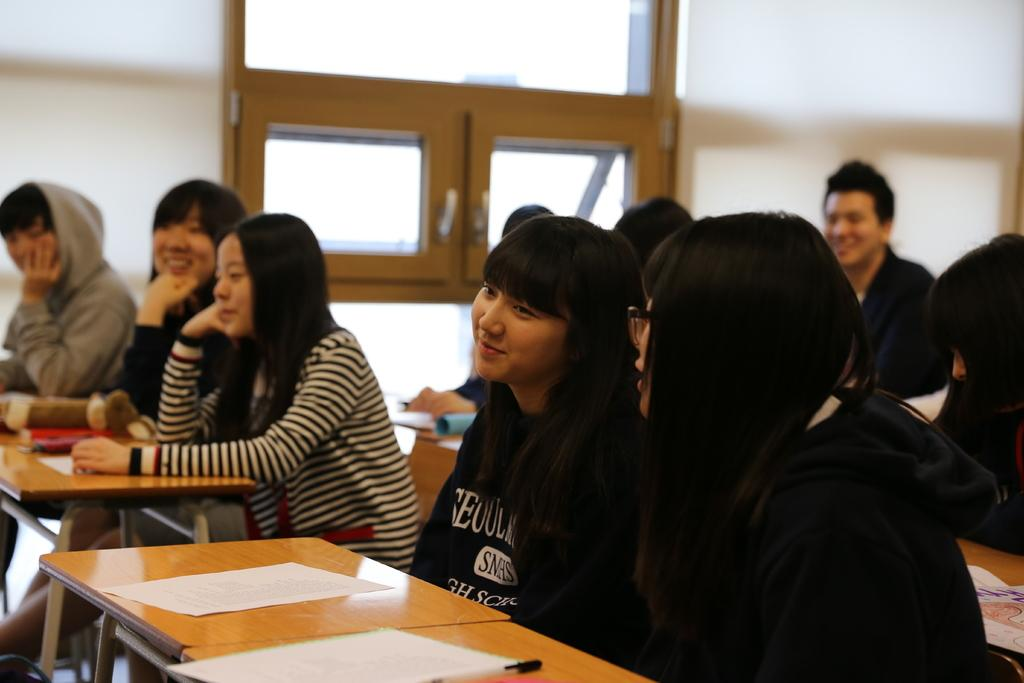What are the people in the image doing? The people in the image are sitting on benches. Can you describe the expressions on the people's faces? Some people in the image have smiles on their faces. What else can be seen in the image besides the people sitting on benches? There are papers visible in the image. What type of cushion is used to support the people sitting on the benches in the image? There is no mention of cushions on the benches in the image, so we cannot determine the type of cushion used. 